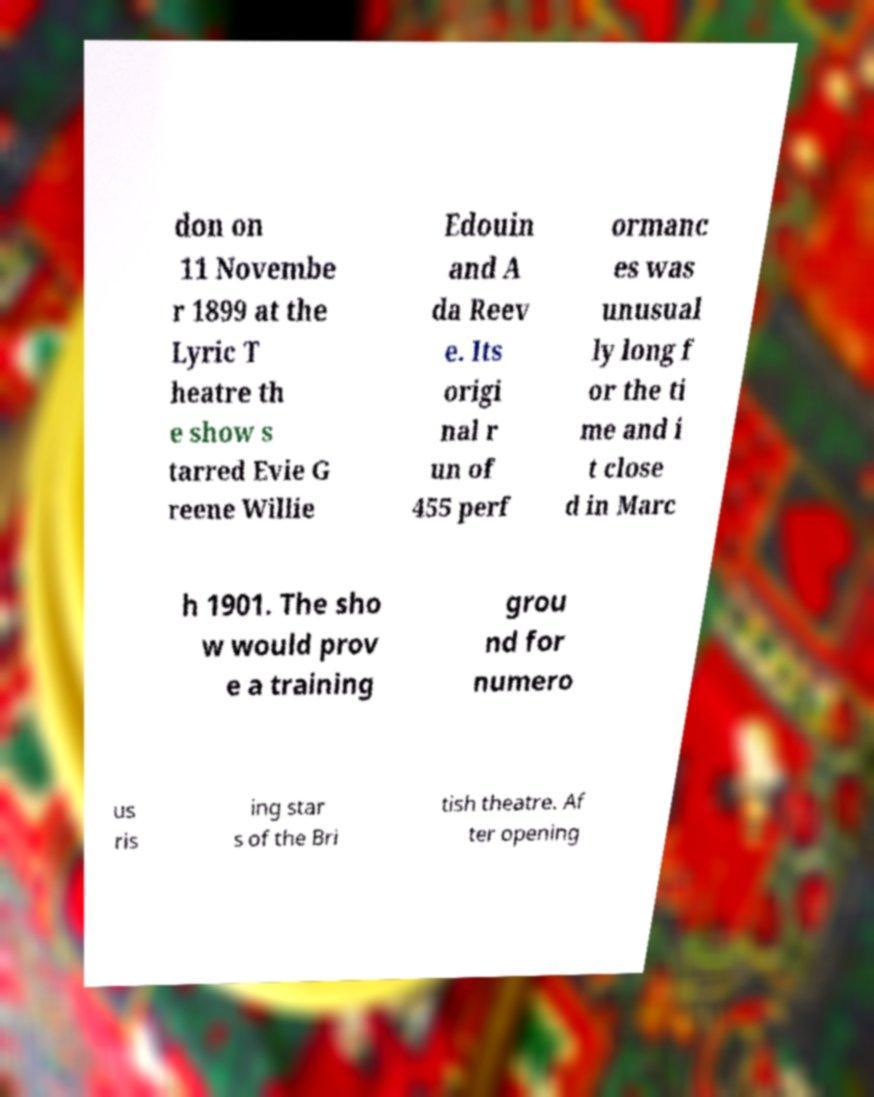Can you accurately transcribe the text from the provided image for me? don on 11 Novembe r 1899 at the Lyric T heatre th e show s tarred Evie G reene Willie Edouin and A da Reev e. Its origi nal r un of 455 perf ormanc es was unusual ly long f or the ti me and i t close d in Marc h 1901. The sho w would prov e a training grou nd for numero us ris ing star s of the Bri tish theatre. Af ter opening 